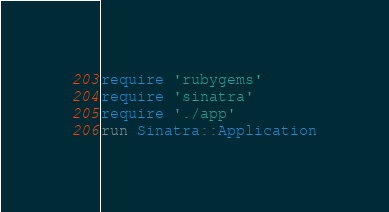Convert code to text. <code><loc_0><loc_0><loc_500><loc_500><_Ruby_>require 'rubygems'
require 'sinatra'
require './app'
run Sinatra::Application
</code> 